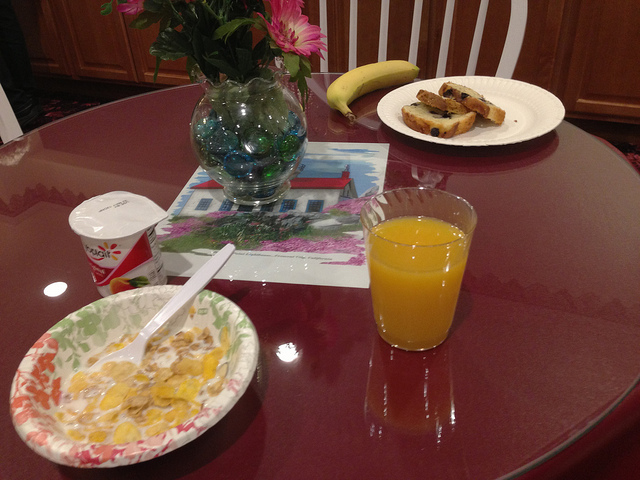Could you suggest a simple recipe using the fruit shown next to the cup of orange juice? Certainly! You can create a delicious banana smoothie. Simply blend the banana with a cup of milk and a few ice cubes for a refreshing drink. Optionally, you can add a spoonful of honey or a scoop of vanilla yogurt for extra sweetness and richness. 